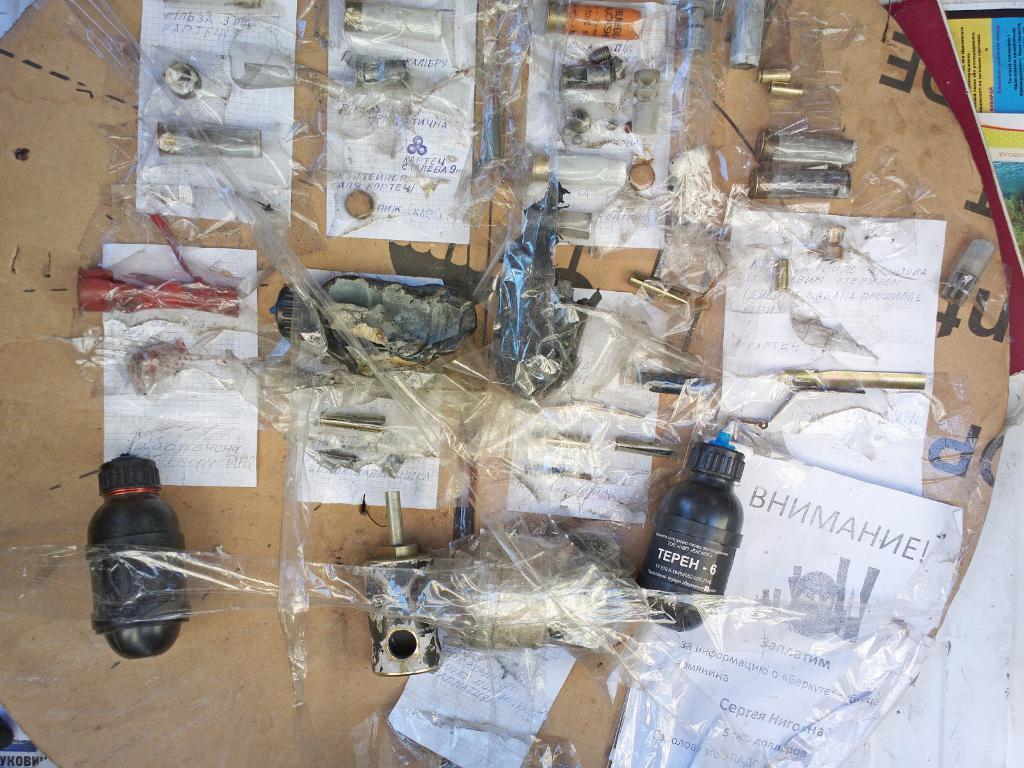Describe this image in one or two sentences. This is a picture in which there are some things on the table and wrapped with a cover. The things are in black, red and orange in color and there are also some papers on the table. 